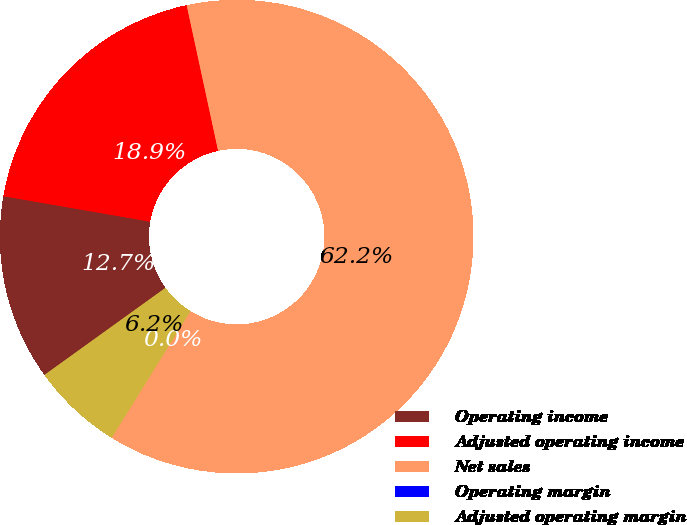Convert chart. <chart><loc_0><loc_0><loc_500><loc_500><pie_chart><fcel>Operating income<fcel>Adjusted operating income<fcel>Net sales<fcel>Operating margin<fcel>Adjusted operating margin<nl><fcel>12.66%<fcel>18.88%<fcel>62.23%<fcel>0.0%<fcel>6.22%<nl></chart> 